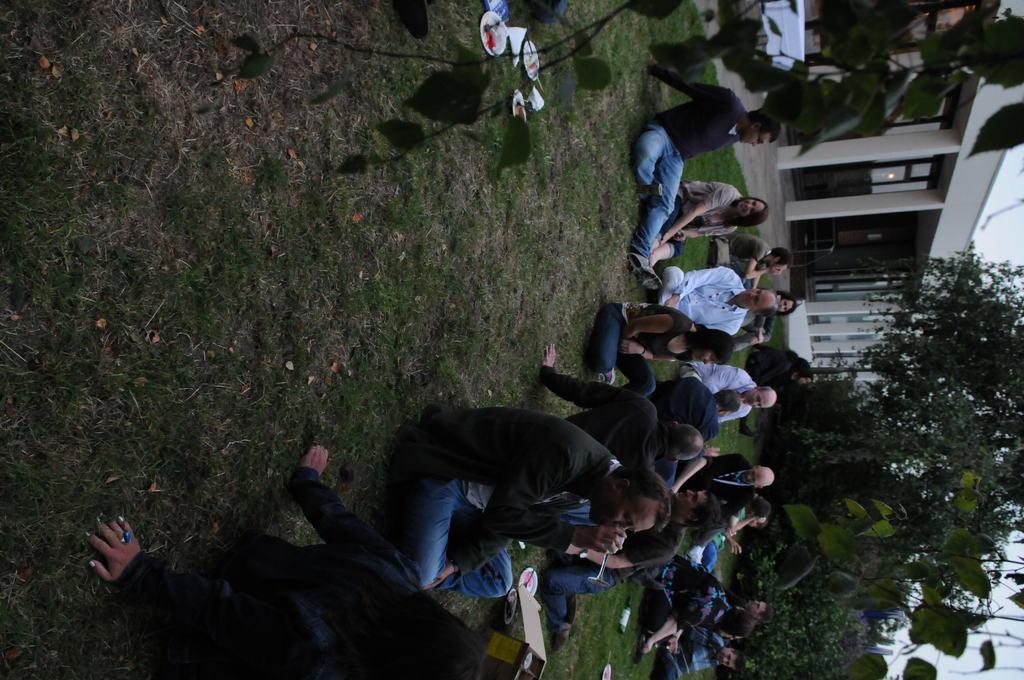Could you give a brief overview of what you see in this image? In this image we can see a few people sitting on the ground, there are some plates, papers, plants, trees and other objects, also we can see a building with pillars and doors. 